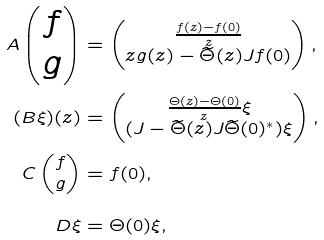<formula> <loc_0><loc_0><loc_500><loc_500>A \begin{pmatrix} f \\ g \end{pmatrix} & = \begin{pmatrix} \frac { f ( z ) - f ( 0 ) } { z } \\ z g ( z ) - \widetilde { \Theta } ( z ) J f ( 0 ) \end{pmatrix} , \\ ( B \xi ) ( z ) & = \begin{pmatrix} \frac { \Theta ( z ) - \Theta ( 0 ) } { z } \xi \\ ( J - \widetilde { \Theta } ( z ) J \widetilde { \Theta } ( 0 ) ^ { * } ) \xi \end{pmatrix} , \\ C \begin{pmatrix} f \\ g \end{pmatrix} & = f ( 0 ) , \\ D \xi & = \Theta ( 0 ) \xi ,</formula> 